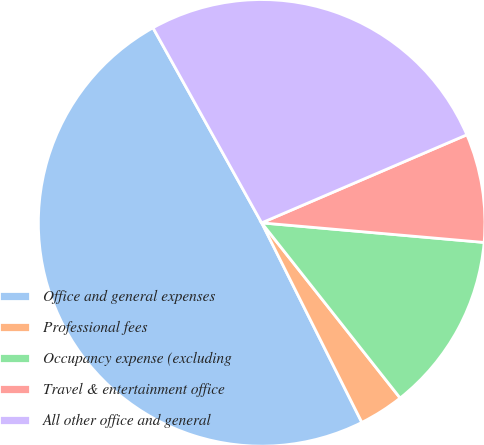Convert chart to OTSL. <chart><loc_0><loc_0><loc_500><loc_500><pie_chart><fcel>Office and general expenses<fcel>Professional fees<fcel>Occupancy expense (excluding<fcel>Travel & entertainment office<fcel>All other office and general<nl><fcel>49.32%<fcel>3.24%<fcel>12.96%<fcel>7.85%<fcel>26.64%<nl></chart> 